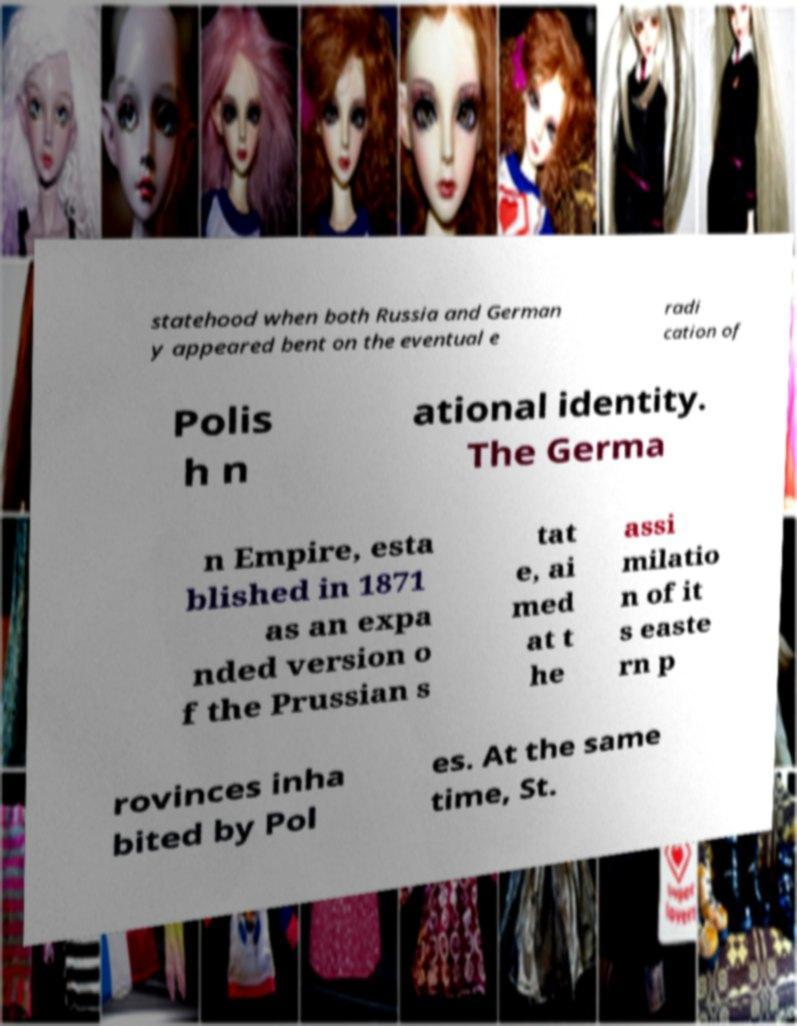For documentation purposes, I need the text within this image transcribed. Could you provide that? statehood when both Russia and German y appeared bent on the eventual e radi cation of Polis h n ational identity. The Germa n Empire, esta blished in 1871 as an expa nded version o f the Prussian s tat e, ai med at t he assi milatio n of it s easte rn p rovinces inha bited by Pol es. At the same time, St. 